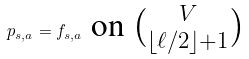<formula> <loc_0><loc_0><loc_500><loc_500>p _ { s , a } = f _ { s , a } \ \text {on $\tbinom{V}{\lfloor \ell/2\rfloor+1}$}</formula> 